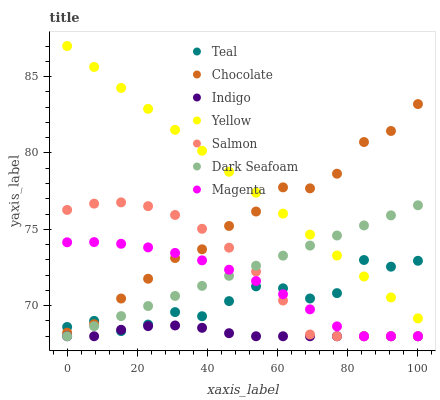Does Indigo have the minimum area under the curve?
Answer yes or no. Yes. Does Yellow have the maximum area under the curve?
Answer yes or no. Yes. Does Salmon have the minimum area under the curve?
Answer yes or no. No. Does Salmon have the maximum area under the curve?
Answer yes or no. No. Is Yellow the smoothest?
Answer yes or no. Yes. Is Teal the roughest?
Answer yes or no. Yes. Is Salmon the smoothest?
Answer yes or no. No. Is Salmon the roughest?
Answer yes or no. No. Does Indigo have the lowest value?
Answer yes or no. Yes. Does Yellow have the lowest value?
Answer yes or no. No. Does Yellow have the highest value?
Answer yes or no. Yes. Does Salmon have the highest value?
Answer yes or no. No. Is Dark Seafoam less than Chocolate?
Answer yes or no. Yes. Is Yellow greater than Magenta?
Answer yes or no. Yes. Does Teal intersect Magenta?
Answer yes or no. Yes. Is Teal less than Magenta?
Answer yes or no. No. Is Teal greater than Magenta?
Answer yes or no. No. Does Dark Seafoam intersect Chocolate?
Answer yes or no. No. 